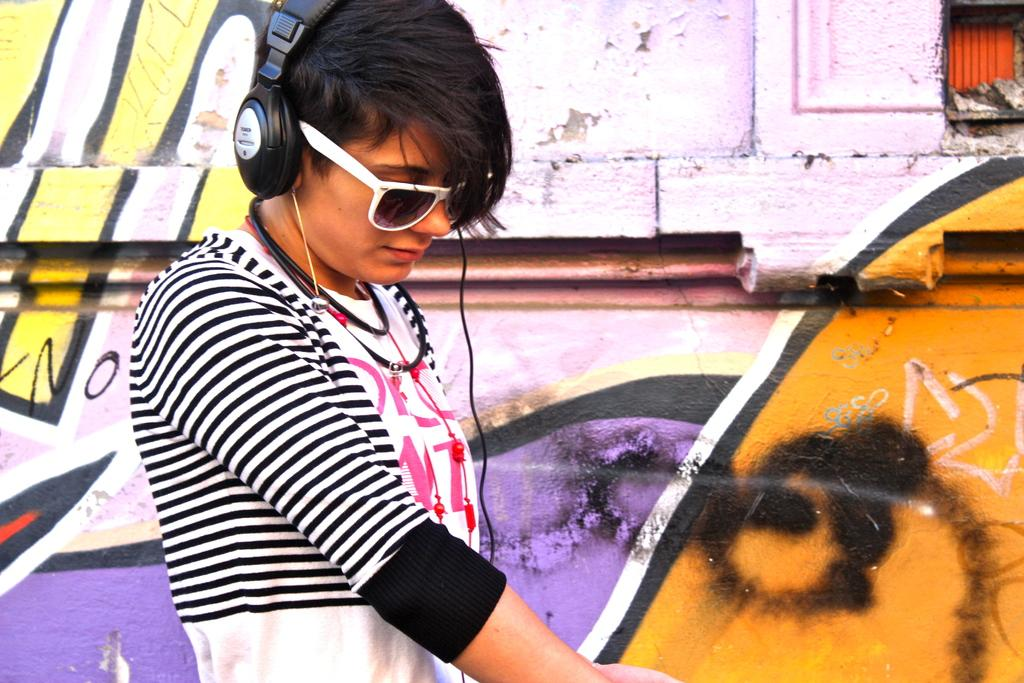What is the person in the image wearing on their body? The person is wearing a black and white dress. What accessories can be seen on the person's head? The person is wearing a headset and goggles. What can be seen on the wall in the background of the image? There is a painting on the wall in the background. What type of snow can be seen falling in the image? There is no snow present in the image. 